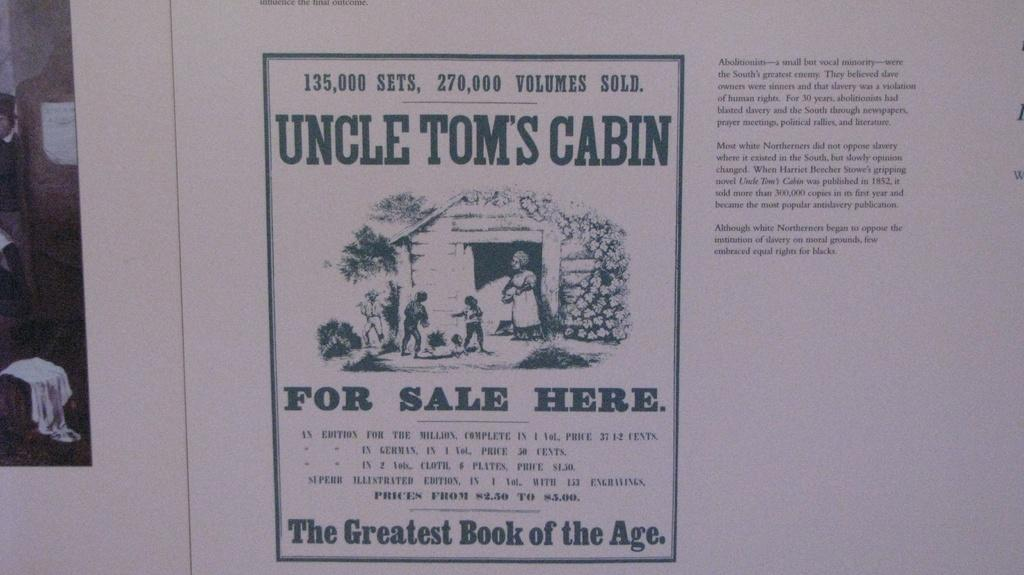<image>
Share a concise interpretation of the image provided. Drawing of some boys and their mother with the phrase "The Greatest Book of the Age" on the bottom. 